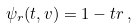<formula> <loc_0><loc_0><loc_500><loc_500>\psi _ { r } ( t , v ) = 1 - t r \, ,</formula> 